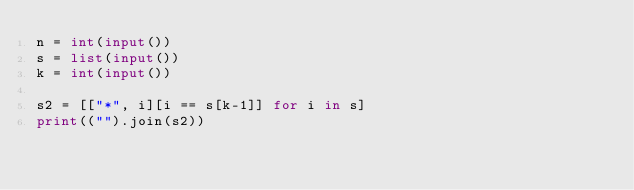<code> <loc_0><loc_0><loc_500><loc_500><_Python_>n = int(input())
s = list(input())
k = int(input())

s2 = [["*", i][i == s[k-1]] for i in s]
print(("").join(s2))</code> 